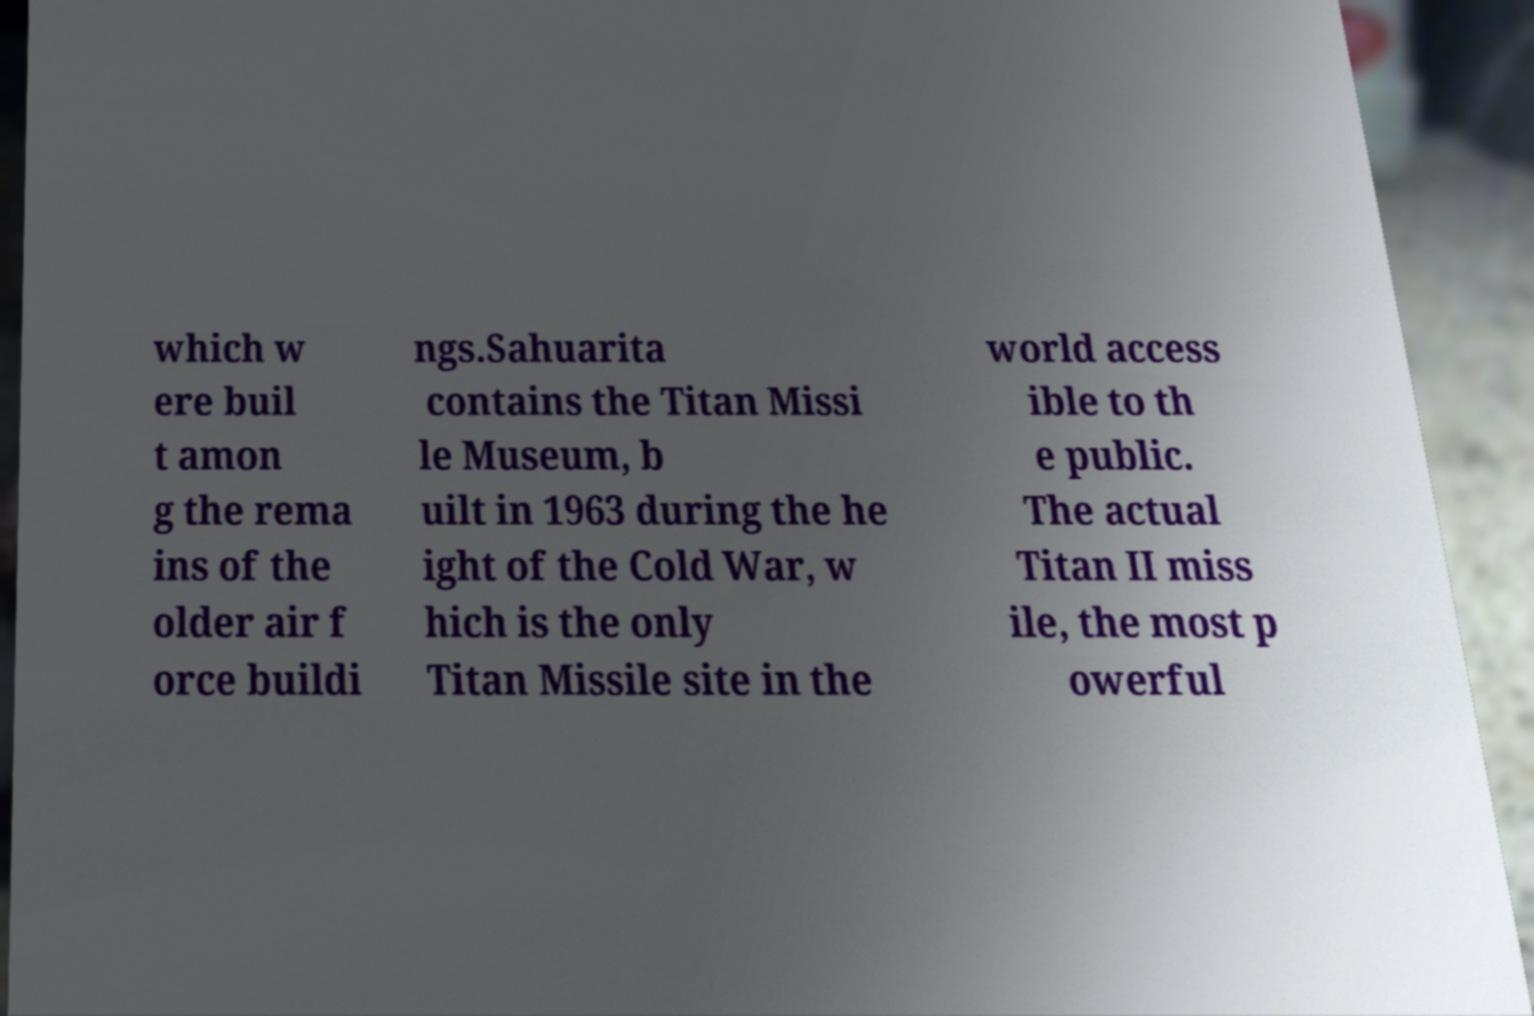What messages or text are displayed in this image? I need them in a readable, typed format. which w ere buil t amon g the rema ins of the older air f orce buildi ngs.Sahuarita contains the Titan Missi le Museum, b uilt in 1963 during the he ight of the Cold War, w hich is the only Titan Missile site in the world access ible to th e public. The actual Titan II miss ile, the most p owerful 